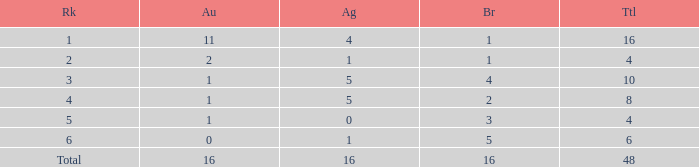How many total gold are less than 4? 0.0. 